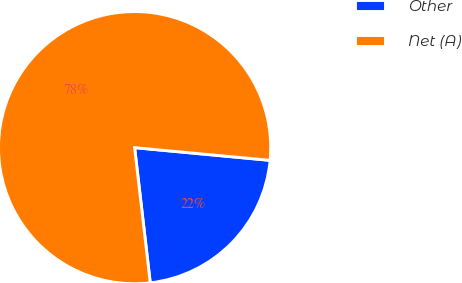Convert chart. <chart><loc_0><loc_0><loc_500><loc_500><pie_chart><fcel>Other<fcel>Net (A)<nl><fcel>21.68%<fcel>78.32%<nl></chart> 